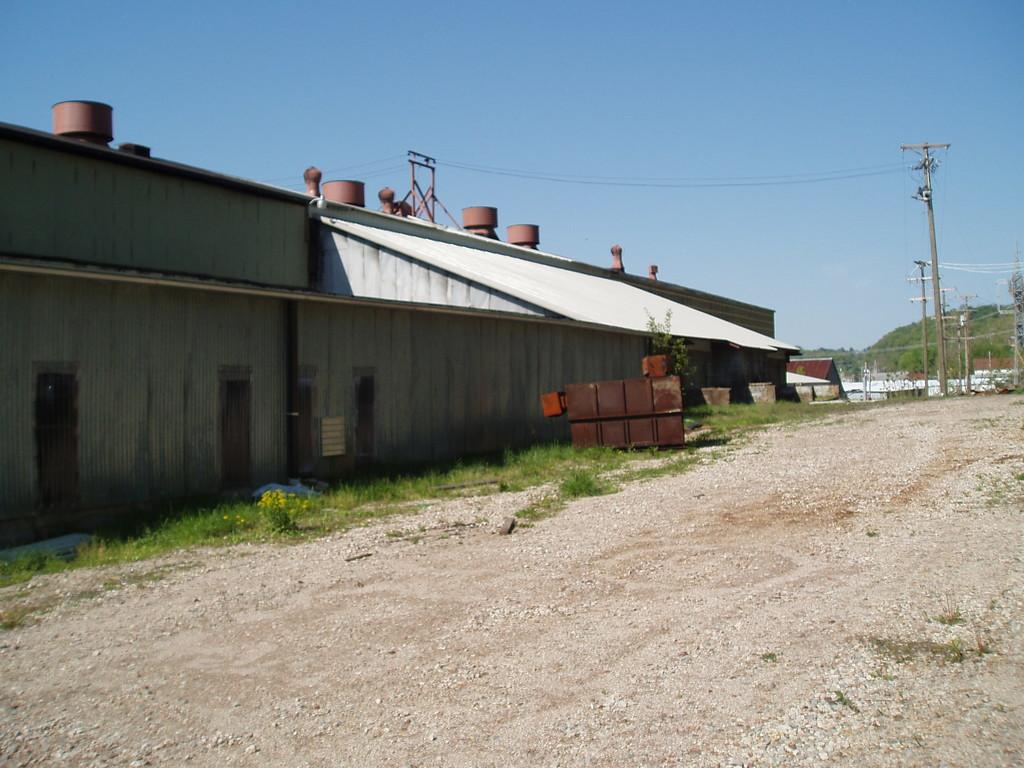What type of surface can be seen at the bottom of the image? The ground is visible in the image. What type of natural elements are present in the image? There are plants and a mountain in the image. What type of man-made structures can be seen in the image? There are buildings in the image. What type of infrastructure elements are present in the image? There are poles and wires in the image. What else can be seen in the image besides the mentioned elements? There are some objects in the image. What can be seen in the background of the image? The sky is visible in the background of the image. Where is the chair located in the image? There is no chair present in the image. What type of cave can be seen in the image? There is no cave present in the image. 